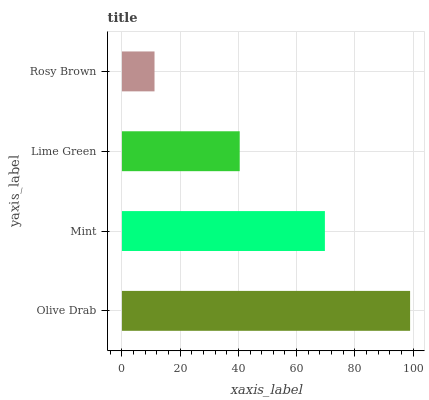Is Rosy Brown the minimum?
Answer yes or no. Yes. Is Olive Drab the maximum?
Answer yes or no. Yes. Is Mint the minimum?
Answer yes or no. No. Is Mint the maximum?
Answer yes or no. No. Is Olive Drab greater than Mint?
Answer yes or no. Yes. Is Mint less than Olive Drab?
Answer yes or no. Yes. Is Mint greater than Olive Drab?
Answer yes or no. No. Is Olive Drab less than Mint?
Answer yes or no. No. Is Mint the high median?
Answer yes or no. Yes. Is Lime Green the low median?
Answer yes or no. Yes. Is Rosy Brown the high median?
Answer yes or no. No. Is Mint the low median?
Answer yes or no. No. 